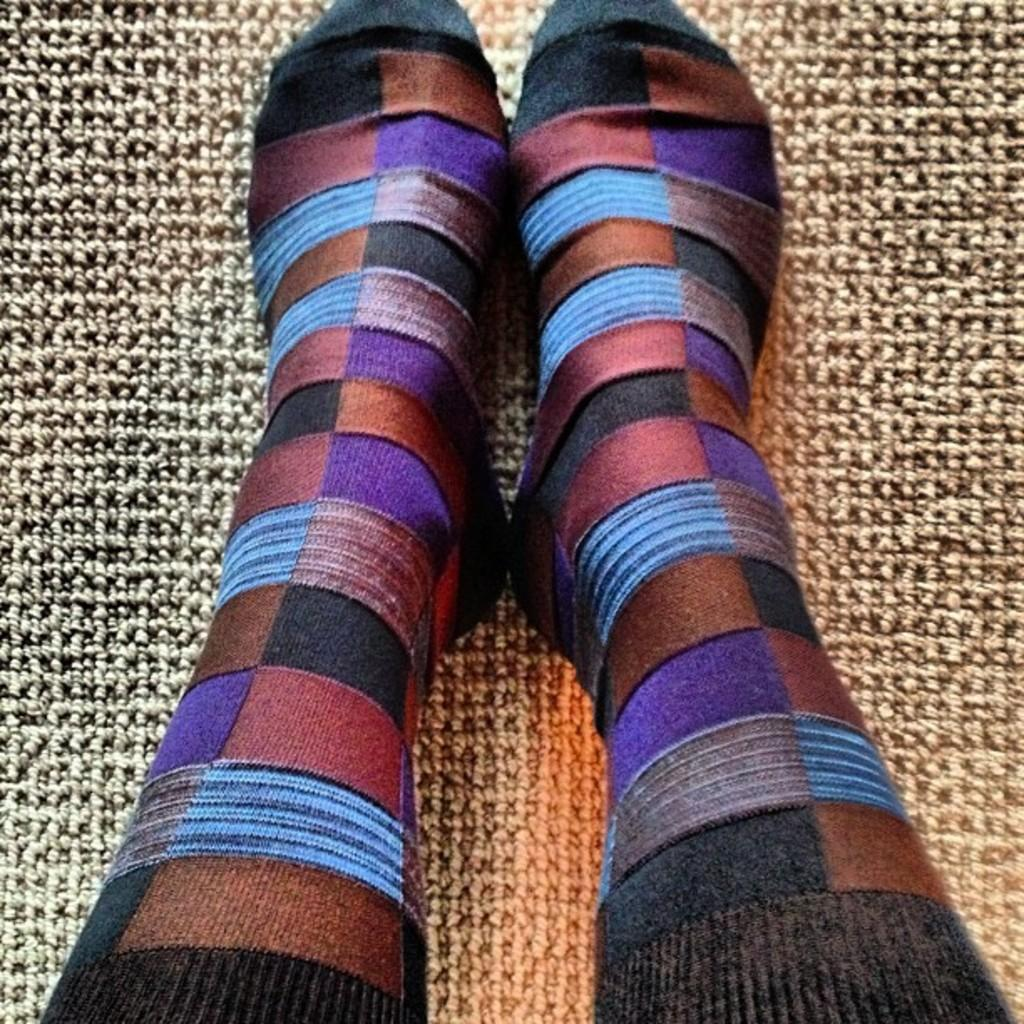What part of a person can be seen in the image? There are legs of a person in the image. What is the person standing on in the image? There is a mat in the image. How much profit can be made from the hammer in the image? There is no hammer present in the image, so it is not possible to determine any profit. 